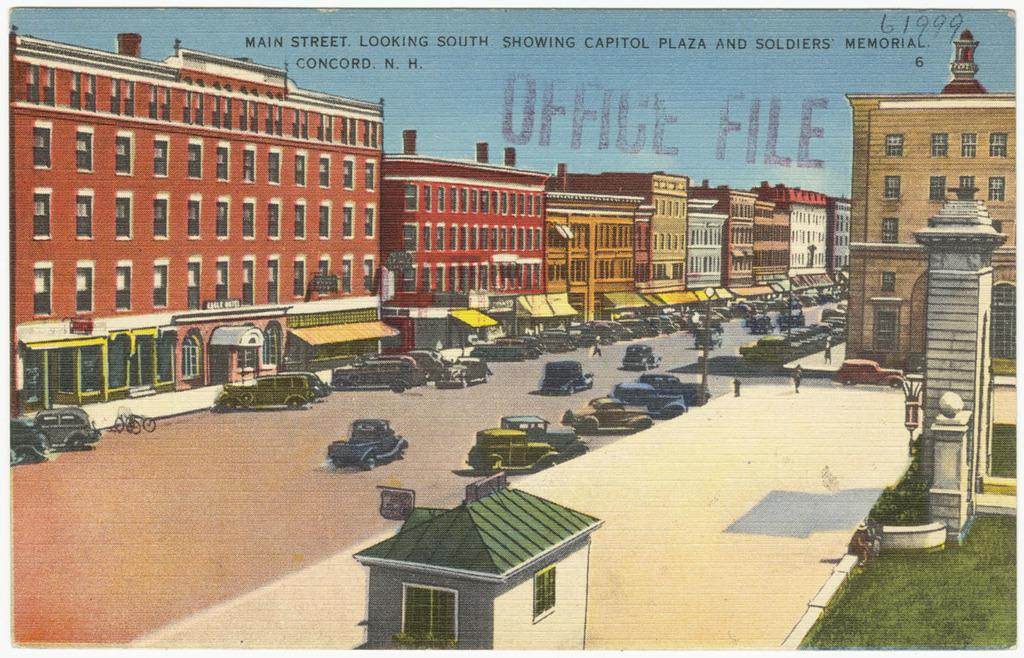What type of visual is the image? The image is a poster. What type of structures can be seen in the image? There are buildings in the image. What type of vehicles are present in the image? There are cars in the image. Where is the text located in the image? The text is at the top of the image. Can you tell me how many volleyballs are being used in the image? There are no volleyballs present in the image. What type of bun is being served at the event in the image? There is no event or bun depicted in the image. 